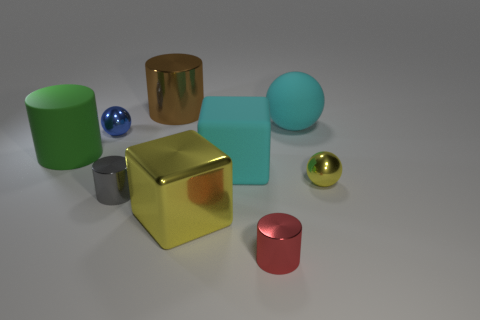Subtract 1 cylinders. How many cylinders are left? 3 Subtract all cyan cylinders. Subtract all brown cubes. How many cylinders are left? 4 Subtract all cylinders. How many objects are left? 5 Subtract 0 purple cylinders. How many objects are left? 9 Subtract all cyan blocks. Subtract all small gray metal objects. How many objects are left? 7 Add 5 yellow balls. How many yellow balls are left? 6 Add 7 large cyan spheres. How many large cyan spheres exist? 8 